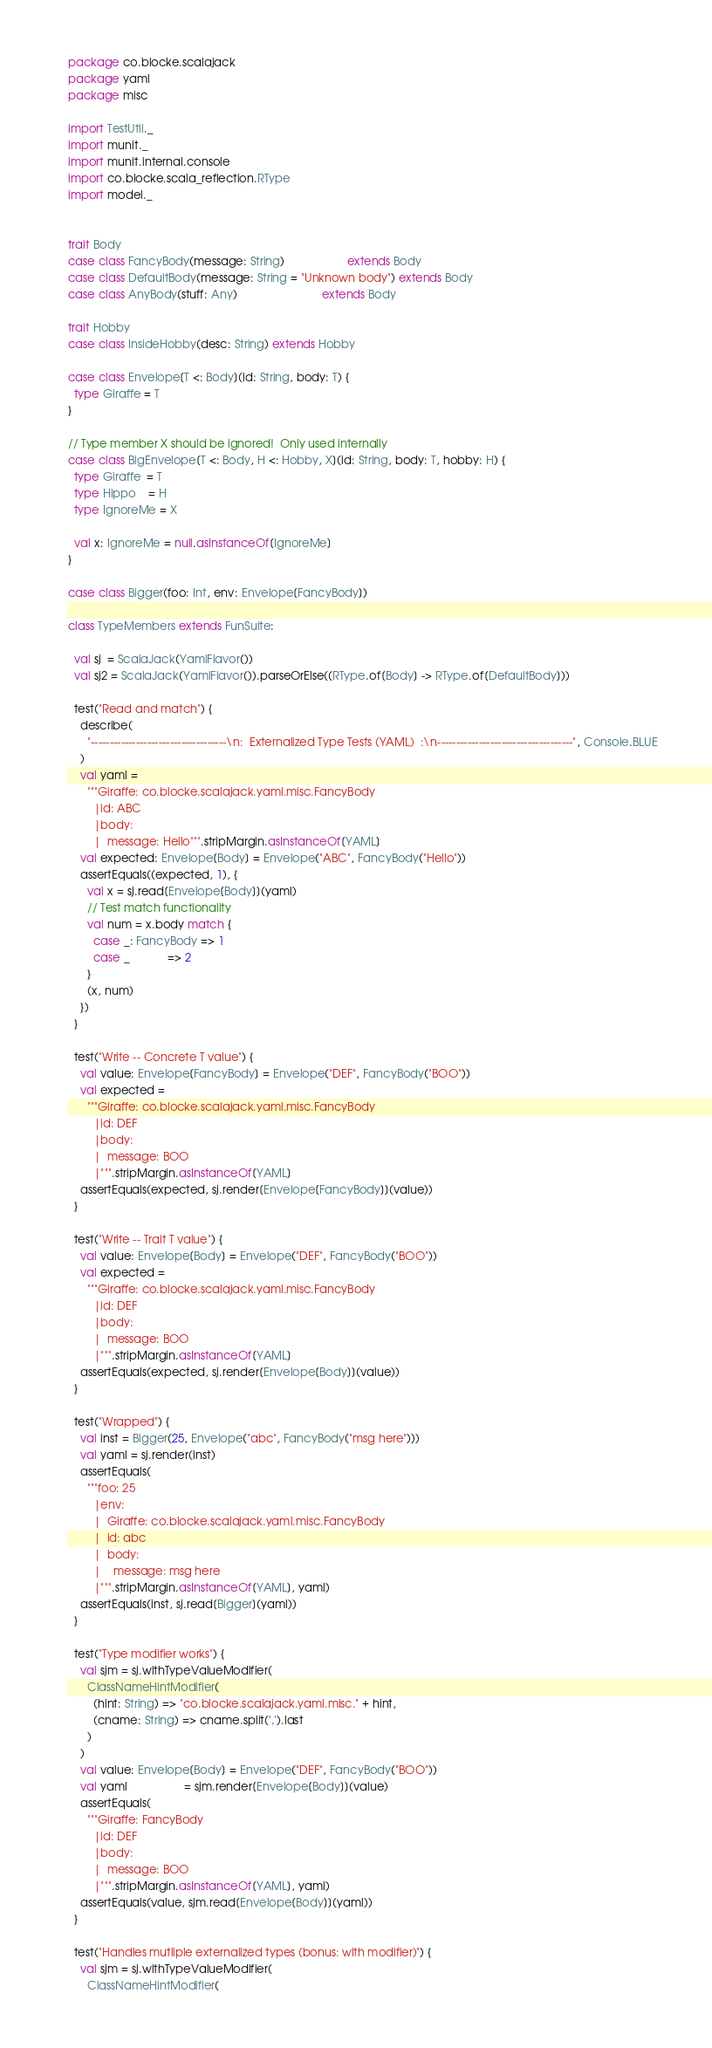<code> <loc_0><loc_0><loc_500><loc_500><_Scala_>package co.blocke.scalajack
package yaml
package misc

import TestUtil._
import munit._
import munit.internal.console
import co.blocke.scala_reflection.RType
import model._


trait Body
case class FancyBody(message: String)                    extends Body
case class DefaultBody(message: String = "Unknown body") extends Body
case class AnyBody(stuff: Any)                           extends Body

trait Hobby
case class InsideHobby(desc: String) extends Hobby

case class Envelope[T <: Body](id: String, body: T) {
  type Giraffe = T
}

// Type member X should be ignored!  Only used internally
case class BigEnvelope[T <: Body, H <: Hobby, X](id: String, body: T, hobby: H) {
  type Giraffe  = T
  type Hippo    = H
  type IgnoreMe = X

  val x: IgnoreMe = null.asInstanceOf[IgnoreMe]
}

case class Bigger(foo: Int, env: Envelope[FancyBody])

class TypeMembers extends FunSuite:

  val sj  = ScalaJack(YamlFlavor())
  val sj2 = ScalaJack(YamlFlavor()).parseOrElse((RType.of[Body] -> RType.of[DefaultBody]))

  test("Read and match") {
    describe(
      "------------------------------------\n:  Externalized Type Tests (YAML)  :\n------------------------------------", Console.BLUE
    )
    val yaml =
      """Giraffe: co.blocke.scalajack.yaml.misc.FancyBody
        |id: ABC
        |body:
        |  message: Hello""".stripMargin.asInstanceOf[YAML]
    val expected: Envelope[Body] = Envelope("ABC", FancyBody("Hello"))
    assertEquals((expected, 1), {
      val x = sj.read[Envelope[Body]](yaml)
      // Test match functionality
      val num = x.body match {
        case _: FancyBody => 1
        case _            => 2
      }
      (x, num)
    })
  }

  test("Write -- Concrete T value") {
    val value: Envelope[FancyBody] = Envelope("DEF", FancyBody("BOO"))
    val expected =
      """Giraffe: co.blocke.scalajack.yaml.misc.FancyBody
        |id: DEF
        |body:
        |  message: BOO
        |""".stripMargin.asInstanceOf[YAML]
    assertEquals(expected, sj.render[Envelope[FancyBody]](value))
  }

  test("Write -- Trait T value") {
    val value: Envelope[Body] = Envelope("DEF", FancyBody("BOO"))
    val expected =
      """Giraffe: co.blocke.scalajack.yaml.misc.FancyBody
        |id: DEF
        |body:
        |  message: BOO
        |""".stripMargin.asInstanceOf[YAML]
    assertEquals(expected, sj.render[Envelope[Body]](value))
  }

  test("Wrapped") {
    val inst = Bigger(25, Envelope("abc", FancyBody("msg here")))
    val yaml = sj.render(inst)
    assertEquals(
      """foo: 25
        |env:
        |  Giraffe: co.blocke.scalajack.yaml.misc.FancyBody
        |  id: abc
        |  body:
        |    message: msg here
        |""".stripMargin.asInstanceOf[YAML], yaml)
    assertEquals(inst, sj.read[Bigger](yaml))
  }

  test("Type modifier works") {
    val sjm = sj.withTypeValueModifier(
      ClassNameHintModifier(
        (hint: String) => "co.blocke.scalajack.yaml.misc." + hint,
        (cname: String) => cname.split('.').last
      )
    )
    val value: Envelope[Body] = Envelope("DEF", FancyBody("BOO"))
    val yaml                  = sjm.render[Envelope[Body]](value)
    assertEquals(
      """Giraffe: FancyBody
        |id: DEF
        |body:
        |  message: BOO
        |""".stripMargin.asInstanceOf[YAML], yaml)
    assertEquals(value, sjm.read[Envelope[Body]](yaml))
  }

  test("Handles mutliple externalized types (bonus: with modifier)") {
    val sjm = sj.withTypeValueModifier(
      ClassNameHintModifier(</code> 